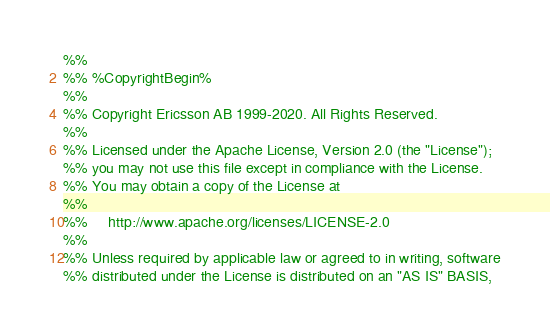<code> <loc_0><loc_0><loc_500><loc_500><_Erlang_>%%
%% %CopyrightBegin%
%%
%% Copyright Ericsson AB 1999-2020. All Rights Reserved.
%%
%% Licensed under the Apache License, Version 2.0 (the "License");
%% you may not use this file except in compliance with the License.
%% You may obtain a copy of the License at
%%
%%     http://www.apache.org/licenses/LICENSE-2.0
%%
%% Unless required by applicable law or agreed to in writing, software
%% distributed under the License is distributed on an "AS IS" BASIS,</code> 